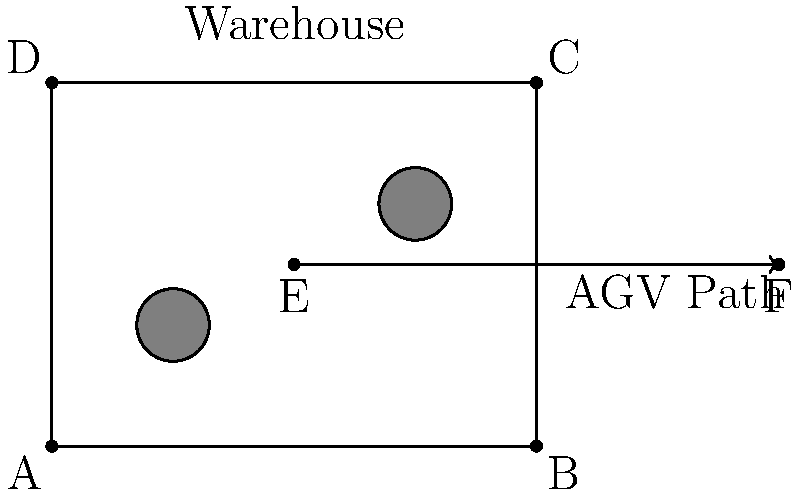An Automated Guided Vehicle (AGV) in a warehouse needs to move from point E (2, 1.5) to point F (6, 1.5) while avoiding obstacles. Given that the AGV can only move in horizontal or vertical directions, determine the optimal sequence of transformations to reach point F using the least number of movements. Express your answer as a composition of translations in the form $T_{(x,y)}$. To optimize the path of the AGV from point E to point F while avoiding obstacles, we need to break down the movement into a series of translations. Let's approach this step-by-step:

1. Analyze the starting and ending points:
   - Start: E (2, 1.5)
   - End: F (6, 1.5)

2. Observe the obstacles:
   - There are two circular obstacles in the path.

3. Plan the optimal path:
   - Move right from E until reaching the y-coordinate of the first obstacle.
   - Move up to avoid the first obstacle.
   - Continue moving right until reaching the x-coordinate of F.
   - Move down to the final y-coordinate of F.

4. Break down the movements into translations:
   - First translation: Move right by 1 unit
     $T_{(1,0)}$
   - Second translation: Move up by 1 unit
     $T_{(0,1)}$
   - Third translation: Move right by 3 units
     $T_{(3,0)}$
   - Fourth translation: Move down by 1 unit
     $T_{(0,-1)}$

5. Compose the translations:
   The final composition of translations is:
   $T_{(0,-1)} \circ T_{(3,0)} \circ T_{(0,1)} \circ T_{(1,0)}$

This sequence of translations ensures that the AGV avoids all obstacles while using the least number of movements to reach point F.
Answer: $T_{(0,-1)} \circ T_{(3,0)} \circ T_{(0,1)} \circ T_{(1,0)}$ 